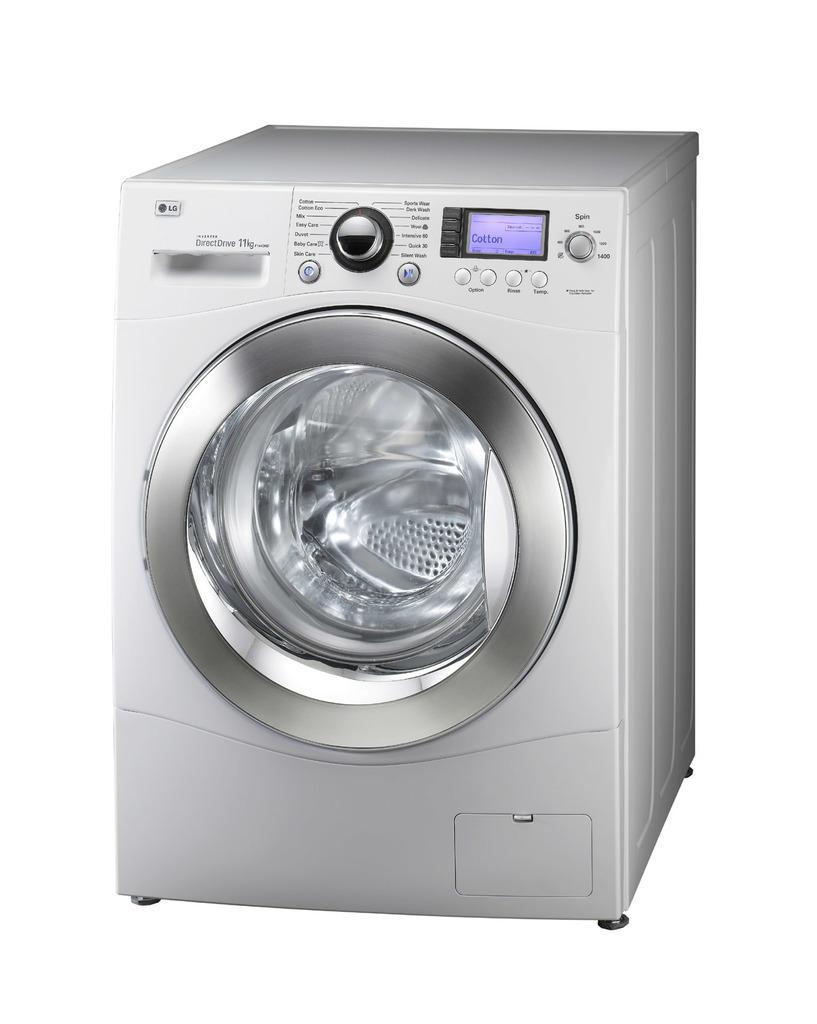Can you describe this image briefly? In this picture there is a washing machine in the center of the image. 